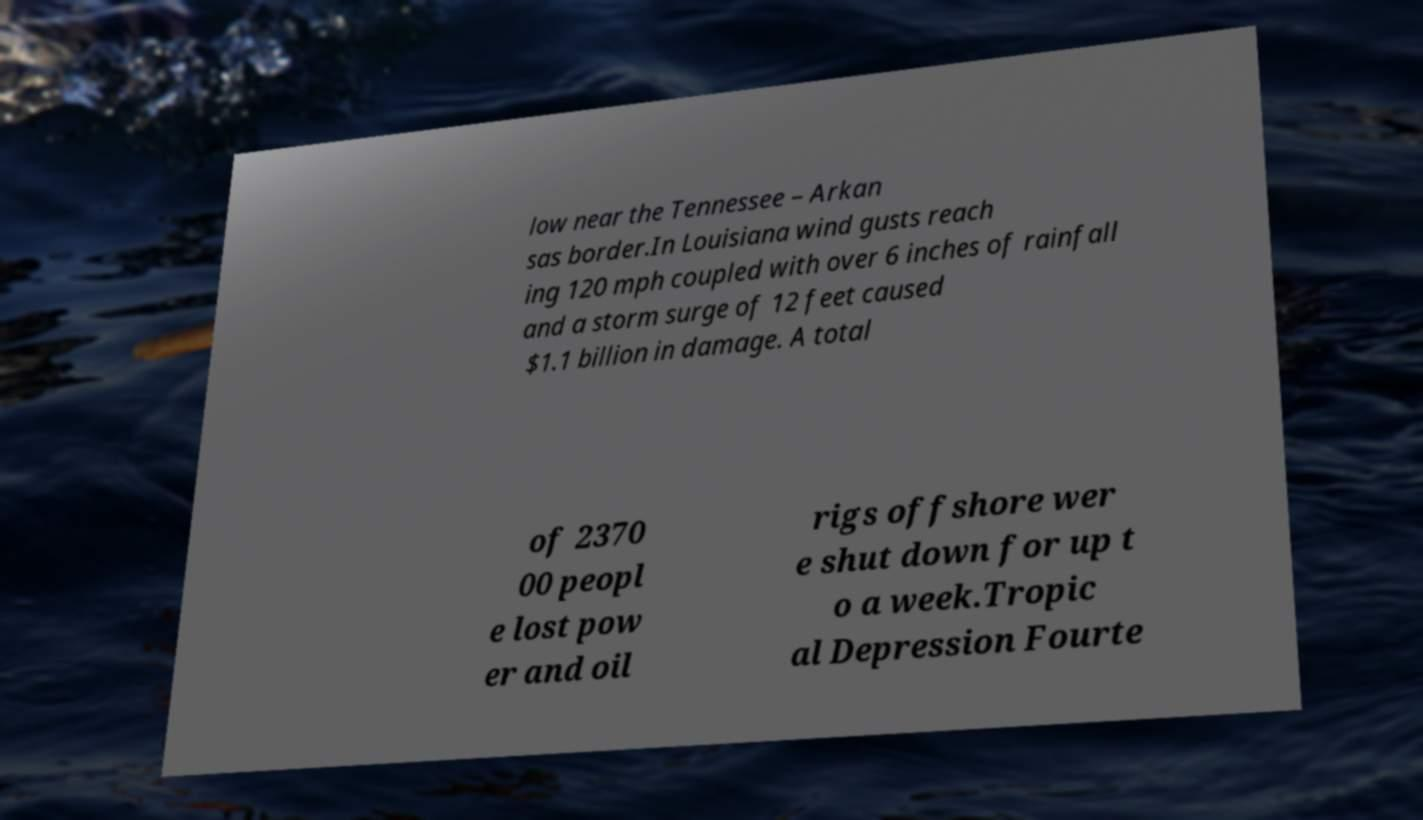Can you read and provide the text displayed in the image?This photo seems to have some interesting text. Can you extract and type it out for me? low near the Tennessee – Arkan sas border.In Louisiana wind gusts reach ing 120 mph coupled with over 6 inches of rainfall and a storm surge of 12 feet caused $1.1 billion in damage. A total of 2370 00 peopl e lost pow er and oil rigs offshore wer e shut down for up t o a week.Tropic al Depression Fourte 